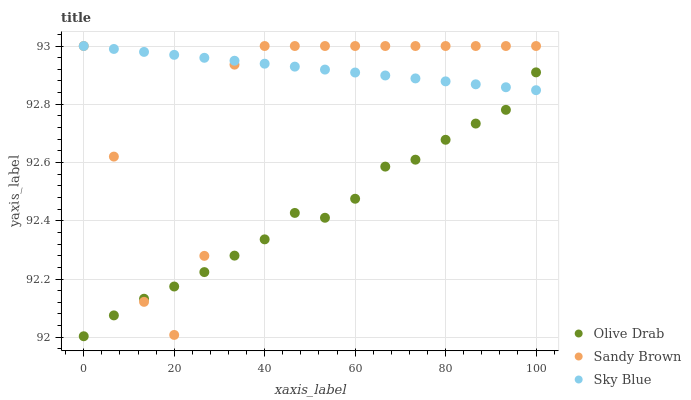Does Olive Drab have the minimum area under the curve?
Answer yes or no. Yes. Does Sky Blue have the maximum area under the curve?
Answer yes or no. Yes. Does Sandy Brown have the minimum area under the curve?
Answer yes or no. No. Does Sandy Brown have the maximum area under the curve?
Answer yes or no. No. Is Sky Blue the smoothest?
Answer yes or no. Yes. Is Sandy Brown the roughest?
Answer yes or no. Yes. Is Olive Drab the smoothest?
Answer yes or no. No. Is Olive Drab the roughest?
Answer yes or no. No. Does Olive Drab have the lowest value?
Answer yes or no. Yes. Does Sandy Brown have the lowest value?
Answer yes or no. No. Does Sandy Brown have the highest value?
Answer yes or no. Yes. Does Olive Drab have the highest value?
Answer yes or no. No. Does Sandy Brown intersect Sky Blue?
Answer yes or no. Yes. Is Sandy Brown less than Sky Blue?
Answer yes or no. No. Is Sandy Brown greater than Sky Blue?
Answer yes or no. No. 